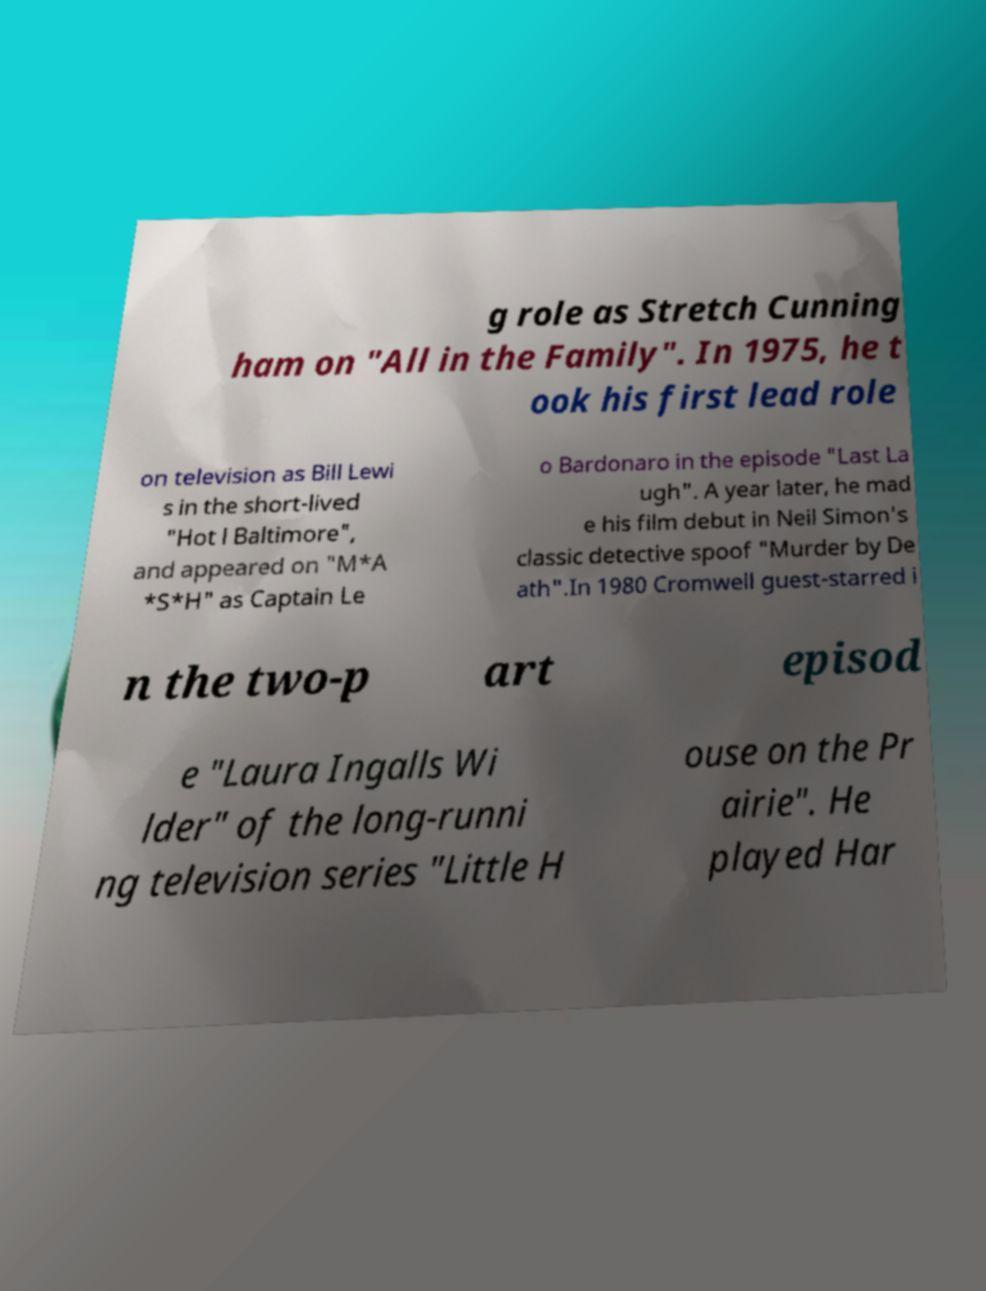Could you extract and type out the text from this image? g role as Stretch Cunning ham on "All in the Family". In 1975, he t ook his first lead role on television as Bill Lewi s in the short-lived "Hot l Baltimore", and appeared on "M*A *S*H" as Captain Le o Bardonaro in the episode "Last La ugh". A year later, he mad e his film debut in Neil Simon's classic detective spoof "Murder by De ath".In 1980 Cromwell guest-starred i n the two-p art episod e "Laura Ingalls Wi lder" of the long-runni ng television series "Little H ouse on the Pr airie". He played Har 